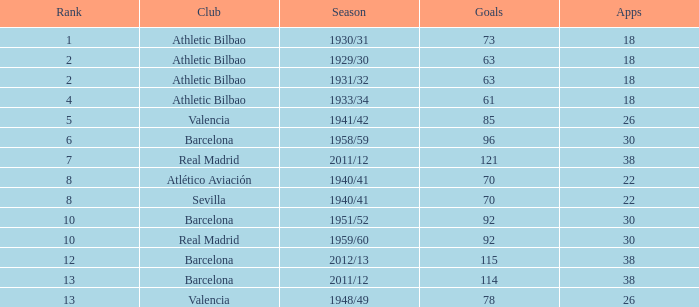How many applications when the position was beyond 13 and possessing over 73 objectives? None. 